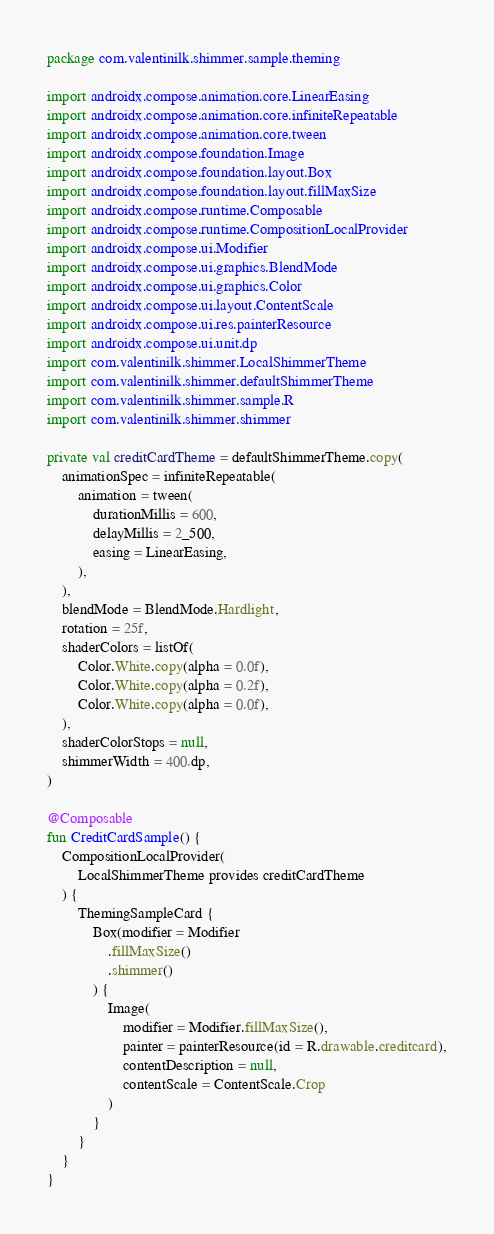Convert code to text. <code><loc_0><loc_0><loc_500><loc_500><_Kotlin_>package com.valentinilk.shimmer.sample.theming

import androidx.compose.animation.core.LinearEasing
import androidx.compose.animation.core.infiniteRepeatable
import androidx.compose.animation.core.tween
import androidx.compose.foundation.Image
import androidx.compose.foundation.layout.Box
import androidx.compose.foundation.layout.fillMaxSize
import androidx.compose.runtime.Composable
import androidx.compose.runtime.CompositionLocalProvider
import androidx.compose.ui.Modifier
import androidx.compose.ui.graphics.BlendMode
import androidx.compose.ui.graphics.Color
import androidx.compose.ui.layout.ContentScale
import androidx.compose.ui.res.painterResource
import androidx.compose.ui.unit.dp
import com.valentinilk.shimmer.LocalShimmerTheme
import com.valentinilk.shimmer.defaultShimmerTheme
import com.valentinilk.shimmer.sample.R
import com.valentinilk.shimmer.shimmer

private val creditCardTheme = defaultShimmerTheme.copy(
    animationSpec = infiniteRepeatable(
        animation = tween(
            durationMillis = 600,
            delayMillis = 2_500,
            easing = LinearEasing,
        ),
    ),
    blendMode = BlendMode.Hardlight,
    rotation = 25f,
    shaderColors = listOf(
        Color.White.copy(alpha = 0.0f),
        Color.White.copy(alpha = 0.2f),
        Color.White.copy(alpha = 0.0f),
    ),
    shaderColorStops = null,
    shimmerWidth = 400.dp,
)

@Composable
fun CreditCardSample() {
    CompositionLocalProvider(
        LocalShimmerTheme provides creditCardTheme
    ) {
        ThemingSampleCard {
            Box(modifier = Modifier
                .fillMaxSize()
                .shimmer()
            ) {
                Image(
                    modifier = Modifier.fillMaxSize(),
                    painter = painterResource(id = R.drawable.creditcard),
                    contentDescription = null,
                    contentScale = ContentScale.Crop
                )
            }
        }
    }
}
</code> 